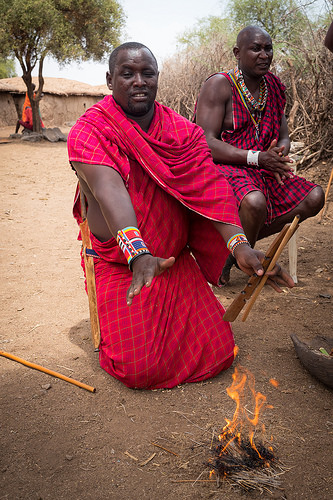<image>
Is the man in front of the fire? No. The man is not in front of the fire. The spatial positioning shows a different relationship between these objects. 